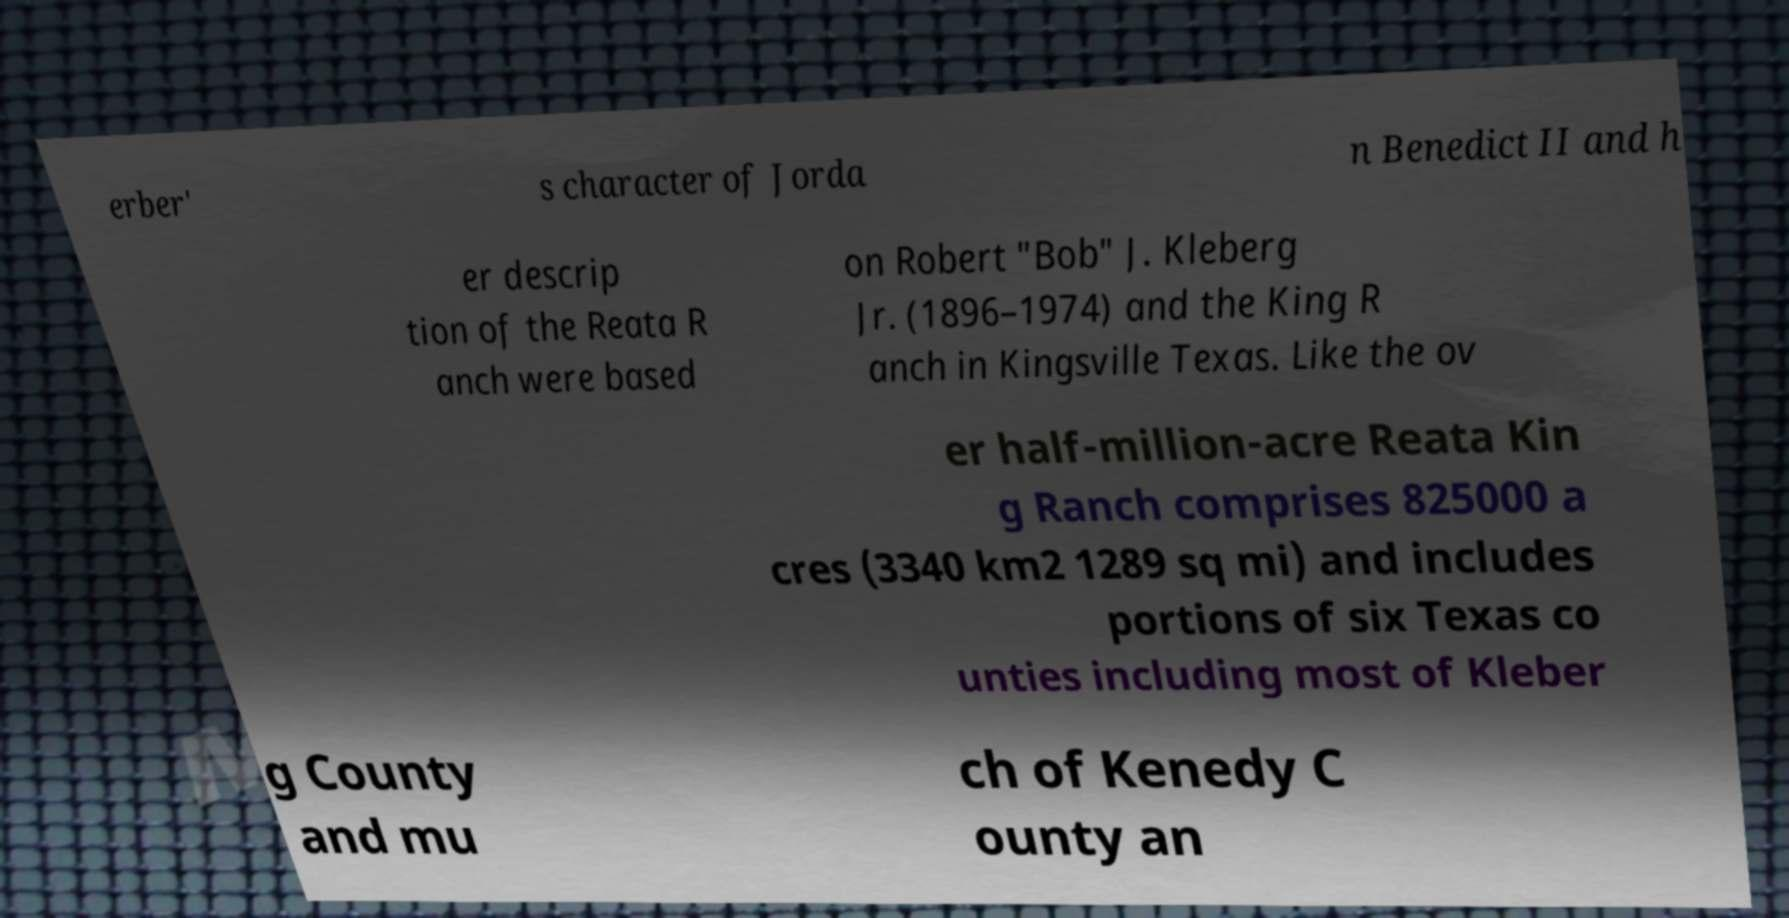Could you assist in decoding the text presented in this image and type it out clearly? erber' s character of Jorda n Benedict II and h er descrip tion of the Reata R anch were based on Robert "Bob" J. Kleberg Jr. (1896–1974) and the King R anch in Kingsville Texas. Like the ov er half-million-acre Reata Kin g Ranch comprises 825000 a cres (3340 km2 1289 sq mi) and includes portions of six Texas co unties including most of Kleber g County and mu ch of Kenedy C ounty an 